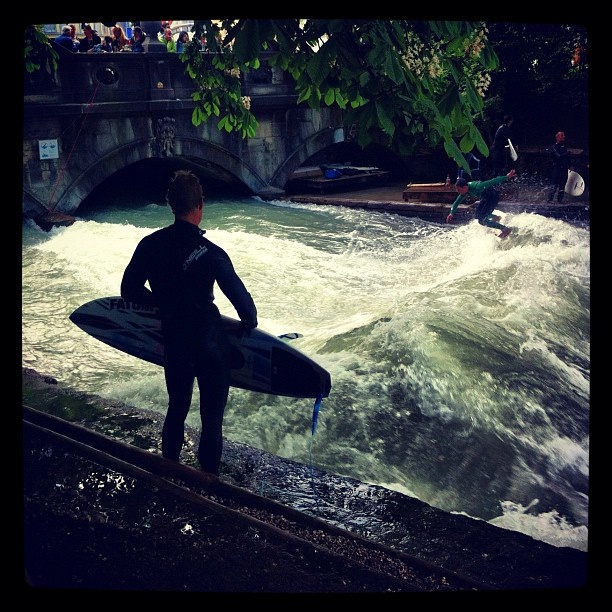Describe the objects in this image and their specific colors. I can see people in black, beige, gray, and navy tones, surfboard in black, navy, beige, and gray tones, people in black, navy, teal, and gray tones, people in black, navy, and purple tones, and people in black, gray, and darkgray tones in this image. 